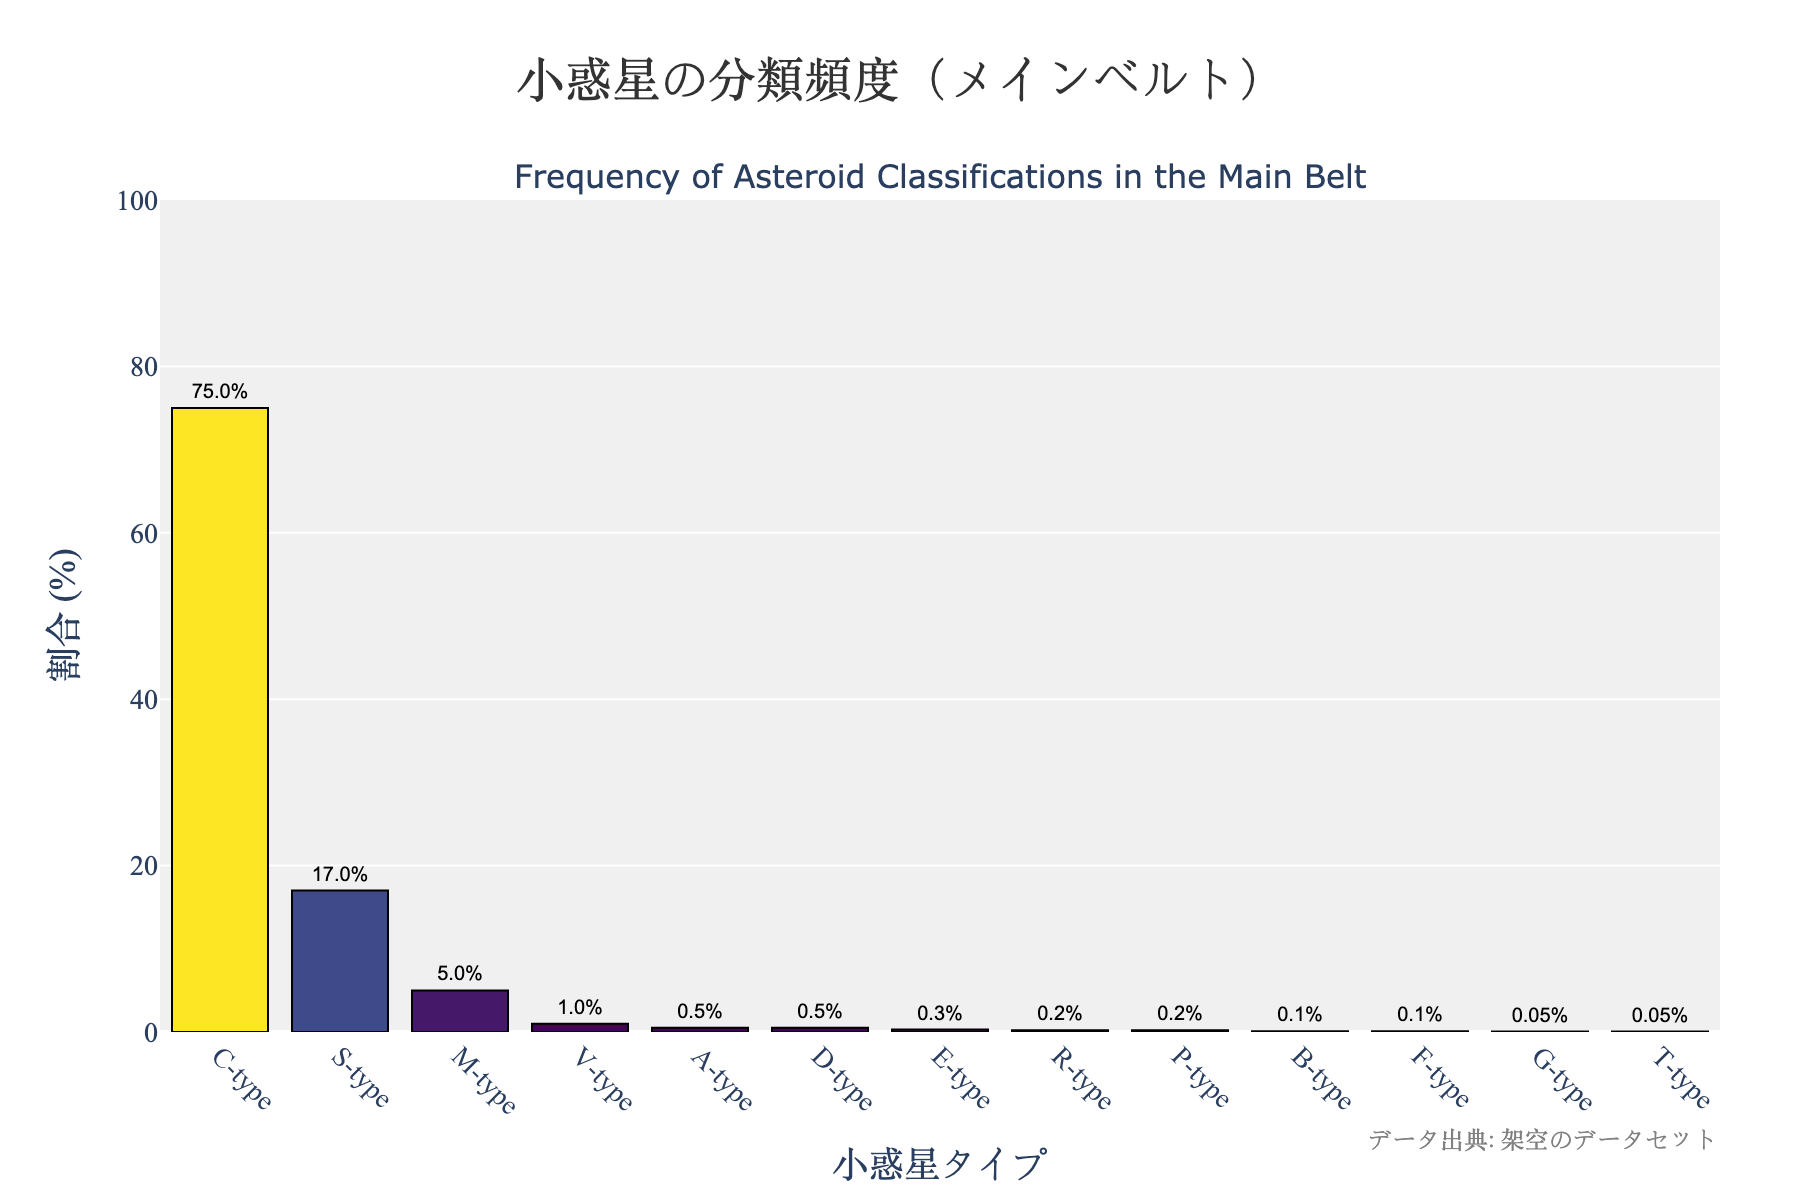Which asteroid classification has the highest frequency? The highest bar in the chart corresponds to the C-type classification. By checking the y-axis label, we can see that C-type represents 75%.
Answer: C-type What is the combined percentage of S-type and M-type asteroids? We need to sum the percentages of S-type (17%) and M-type (5%). 17% + 5% equals 22%.
Answer: 22% How many asteroid classifications have a frequency of less than 1%? By observing the bars shorter than 1% on the y-axis, we find that V-type, A-type, D-type, E-type, R-type, P-type, B-type, F-type, G-type, and T-type all fall below 1%. There are 10 such classifications.
Answer: 10 What is the difference in frequency between C-type and S-type asteroids? We subtract the frequency of S-type (17%) from C-type (75%). 75% - 17% equals 58%.
Answer: 58% Which asteroid classification has the lowest frequency? The lowest bars correspond to G-type and T-type, each labeled with 0.05%.
Answer: G-type and T-type Compare the frequency of V-type asteroids to that of M-type asteroids. Which type has a higher frequency? From the chart, V-type has 1% frequency, while M-type has 5%. Therefore, M-type has a higher frequency.
Answer: M-type Find the total percentage of asteroid classifications that each have more than 10% frequency. Only C-type (75%) fits this criteria. So the total percentage is 75%.
Answer: 75% What is the color pattern in the chart used to differentiate the bars? The colors of the bars follow a gradient from yellow to dark green based on their frequency, where higher percentages correspond to lighter colors.
Answer: Yellow to dark green 